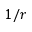Convert formula to latex. <formula><loc_0><loc_0><loc_500><loc_500>1 / r</formula> 